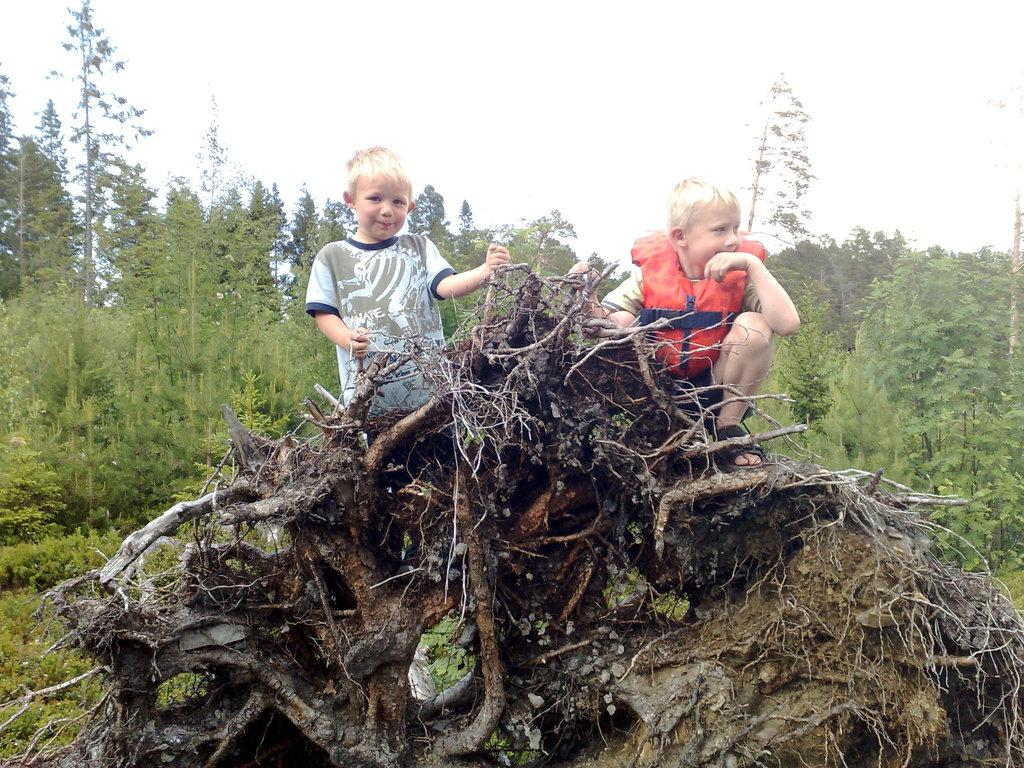What is the main subject of the image? There is a child in the image. What is the child wearing? The child is wearing a white t-shirt and a life jacket. Where is the child sitting? The child is sitting on a tree trunk. What can be seen in the background of the image? There are trees and the sky visible in the background of the image. What type of stone is the child using to communicate with the group in the image? There is no stone or group present in the image; it features a child sitting on a tree trunk wearing a white t-shirt and a life jacket, with trees and the sky visible in the background. 